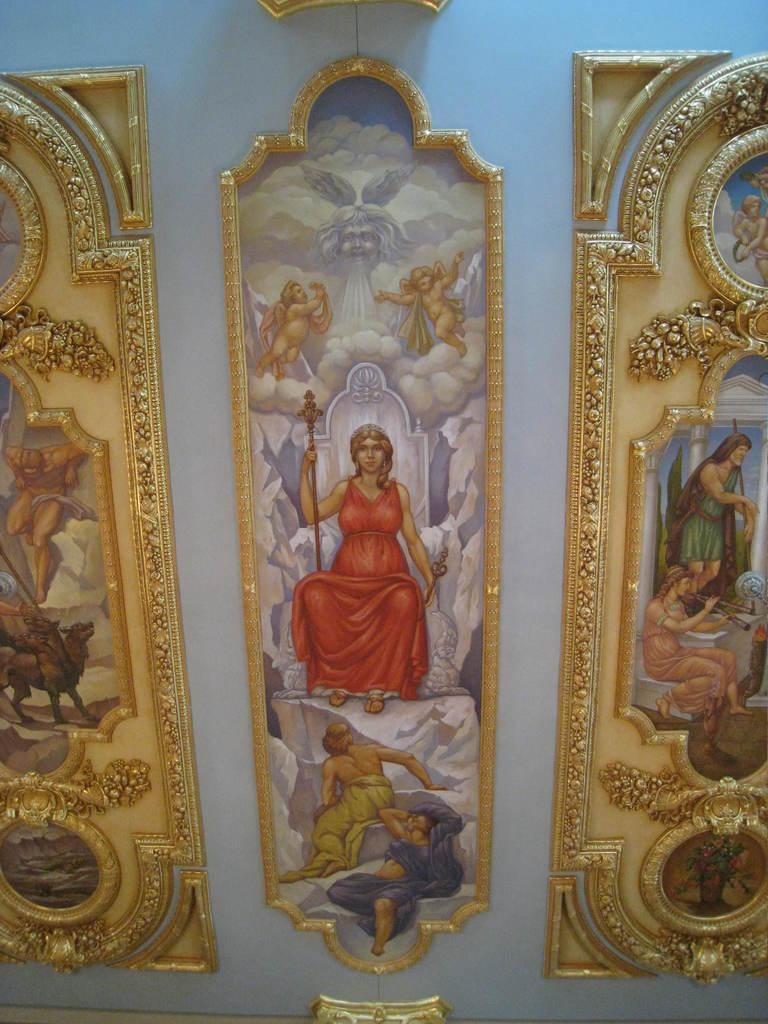What objects can be seen in the image? There are photo frames in the image. Where are the photo frames located? The photo frames are attached to a white color wall. What type of clam is featured in one of the photo frames? There is no clam present in the image, as the photo frames contain unspecified images or subjects. 